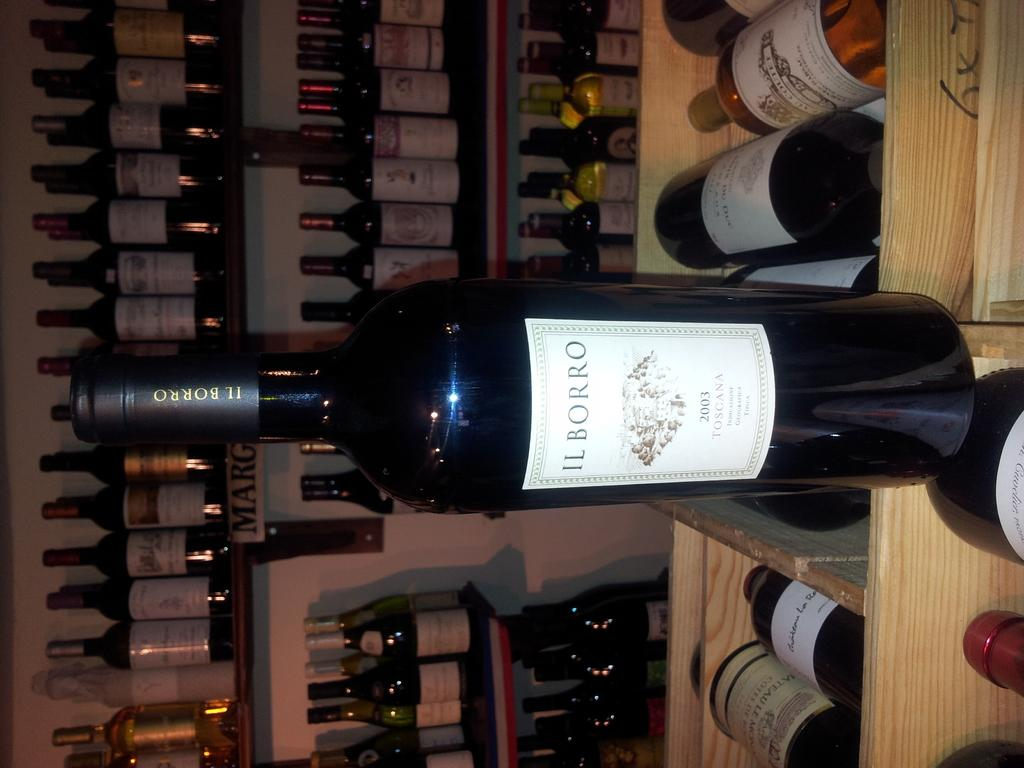<image>
Write a terse but informative summary of the picture. A bottle of IL BORRO wine is standing up on a wine rack in front of several other bottles of wine. 